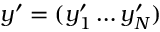Convert formula to latex. <formula><loc_0><loc_0><loc_500><loc_500>y ^ { \prime } = ( y _ { 1 } ^ { \prime } \dots y _ { N } ^ { \prime } )</formula> 